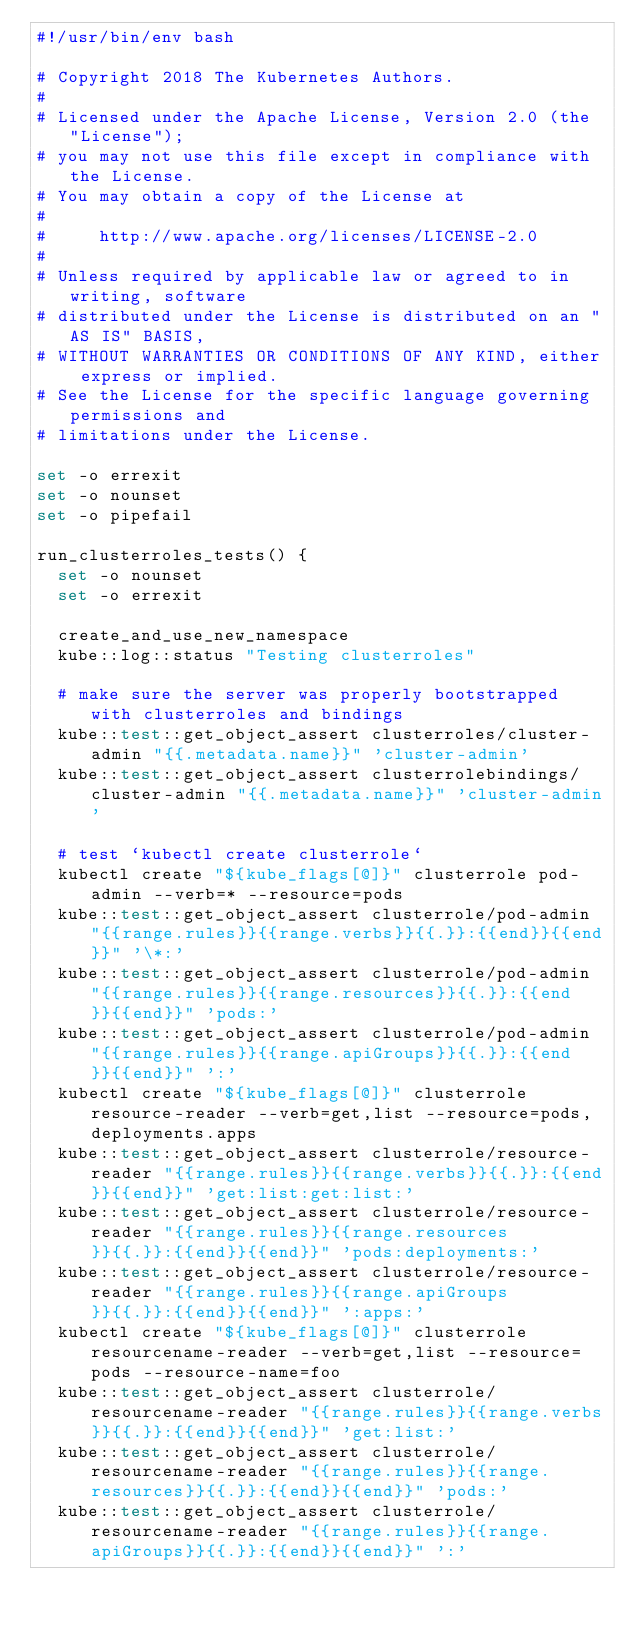<code> <loc_0><loc_0><loc_500><loc_500><_Bash_>#!/usr/bin/env bash

# Copyright 2018 The Kubernetes Authors.
#
# Licensed under the Apache License, Version 2.0 (the "License");
# you may not use this file except in compliance with the License.
# You may obtain a copy of the License at
#
#     http://www.apache.org/licenses/LICENSE-2.0
#
# Unless required by applicable law or agreed to in writing, software
# distributed under the License is distributed on an "AS IS" BASIS,
# WITHOUT WARRANTIES OR CONDITIONS OF ANY KIND, either express or implied.
# See the License for the specific language governing permissions and
# limitations under the License.

set -o errexit
set -o nounset
set -o pipefail

run_clusterroles_tests() {
  set -o nounset
  set -o errexit

  create_and_use_new_namespace
  kube::log::status "Testing clusterroles"

  # make sure the server was properly bootstrapped with clusterroles and bindings
  kube::test::get_object_assert clusterroles/cluster-admin "{{.metadata.name}}" 'cluster-admin'
  kube::test::get_object_assert clusterrolebindings/cluster-admin "{{.metadata.name}}" 'cluster-admin'

  # test `kubectl create clusterrole`
  kubectl create "${kube_flags[@]}" clusterrole pod-admin --verb=* --resource=pods
  kube::test::get_object_assert clusterrole/pod-admin "{{range.rules}}{{range.verbs}}{{.}}:{{end}}{{end}}" '\*:'
  kube::test::get_object_assert clusterrole/pod-admin "{{range.rules}}{{range.resources}}{{.}}:{{end}}{{end}}" 'pods:'
  kube::test::get_object_assert clusterrole/pod-admin "{{range.rules}}{{range.apiGroups}}{{.}}:{{end}}{{end}}" ':'
  kubectl create "${kube_flags[@]}" clusterrole resource-reader --verb=get,list --resource=pods,deployments.apps
  kube::test::get_object_assert clusterrole/resource-reader "{{range.rules}}{{range.verbs}}{{.}}:{{end}}{{end}}" 'get:list:get:list:'
  kube::test::get_object_assert clusterrole/resource-reader "{{range.rules}}{{range.resources}}{{.}}:{{end}}{{end}}" 'pods:deployments:'
  kube::test::get_object_assert clusterrole/resource-reader "{{range.rules}}{{range.apiGroups}}{{.}}:{{end}}{{end}}" ':apps:'
  kubectl create "${kube_flags[@]}" clusterrole resourcename-reader --verb=get,list --resource=pods --resource-name=foo
  kube::test::get_object_assert clusterrole/resourcename-reader "{{range.rules}}{{range.verbs}}{{.}}:{{end}}{{end}}" 'get:list:'
  kube::test::get_object_assert clusterrole/resourcename-reader "{{range.rules}}{{range.resources}}{{.}}:{{end}}{{end}}" 'pods:'
  kube::test::get_object_assert clusterrole/resourcename-reader "{{range.rules}}{{range.apiGroups}}{{.}}:{{end}}{{end}}" ':'</code> 